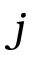<formula> <loc_0><loc_0><loc_500><loc_500>j</formula> 